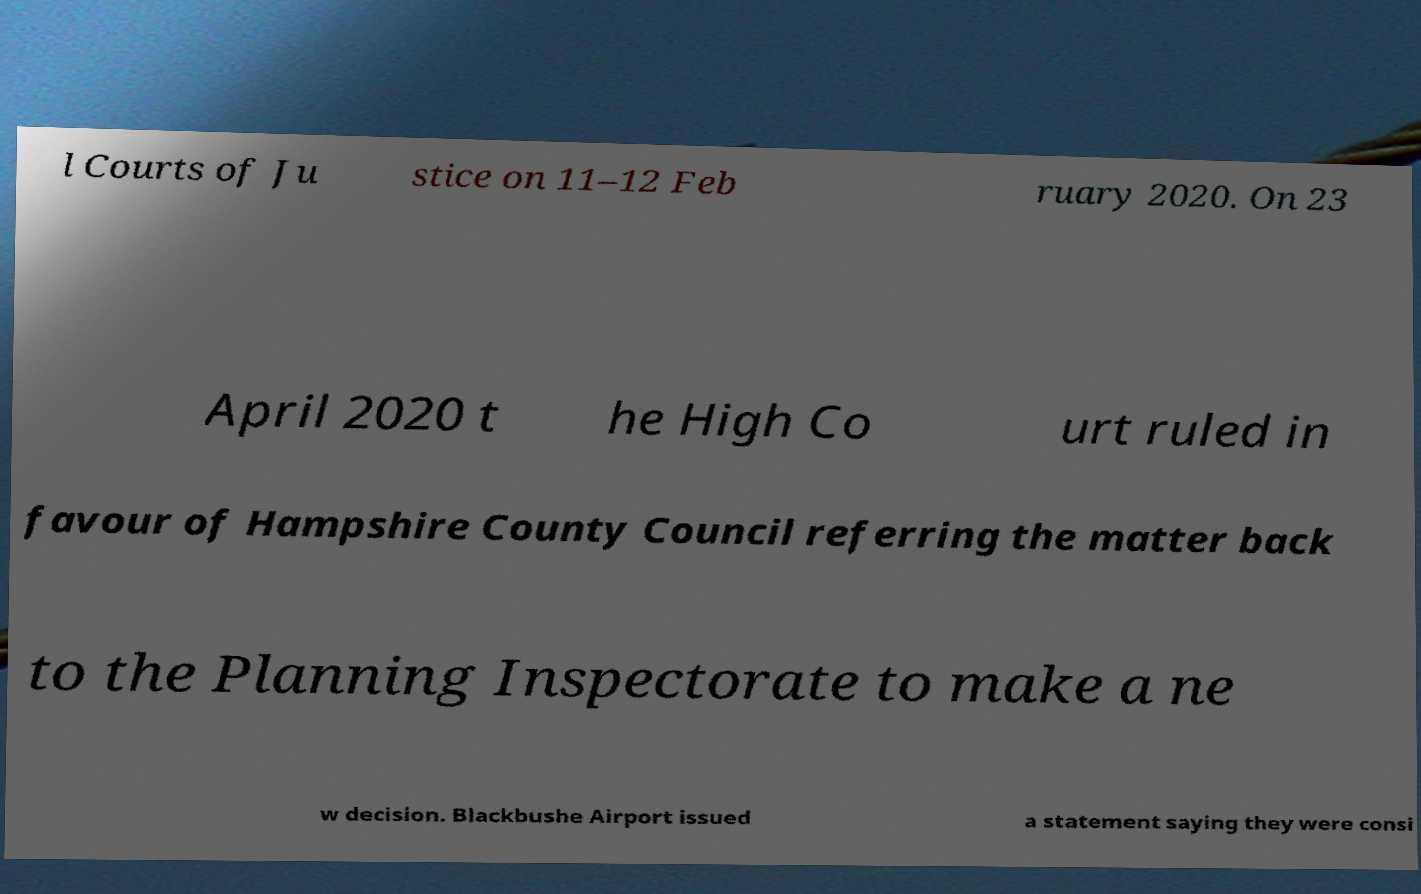I need the written content from this picture converted into text. Can you do that? l Courts of Ju stice on 11–12 Feb ruary 2020. On 23 April 2020 t he High Co urt ruled in favour of Hampshire County Council referring the matter back to the Planning Inspectorate to make a ne w decision. Blackbushe Airport issued a statement saying they were consi 